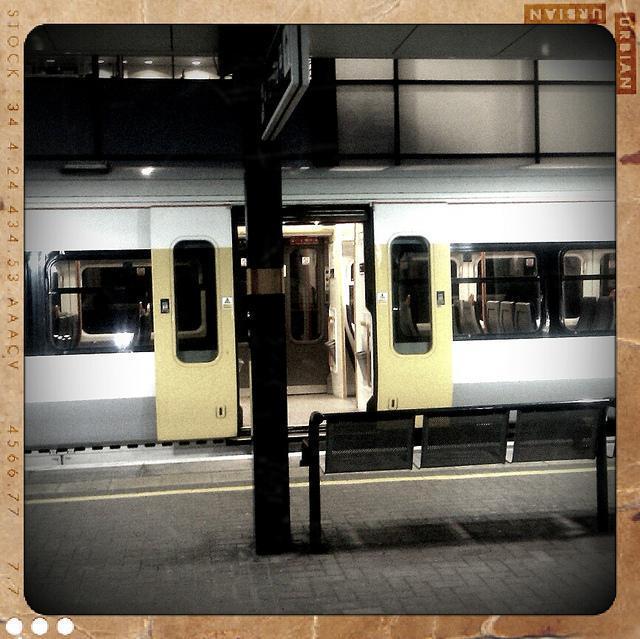How many trains are in the picture?
Give a very brief answer. 1. 